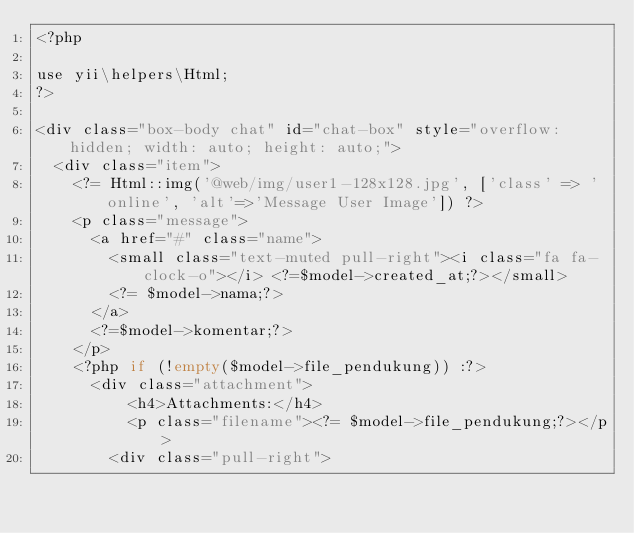Convert code to text. <code><loc_0><loc_0><loc_500><loc_500><_PHP_><?php

use yii\helpers\Html;
?>

<div class="box-body chat" id="chat-box" style="overflow: hidden; width: auto; height: auto;">
  <div class="item">            
    <?= Html::img('@web/img/user1-128x128.jpg', ['class' => 'online', 'alt'=>'Message User Image']) ?>                  
    <p class="message">
      <a href="#" class="name">
        <small class="text-muted pull-right"><i class="fa fa-clock-o"></i> <?=$model->created_at;?></small>
        <?= $model->nama;?>
      </a>
      <?=$model->komentar;?>
    </p>
    <?php if (!empty($model->file_pendukung)) :?>
      <div class="attachment">
          <h4>Attachments:</h4>
          <p class="filename"><?= $model->file_pendukung;?></p>
        <div class="pull-right"></code> 